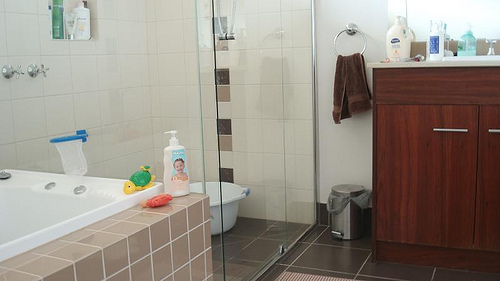Please provide a short description for this region: [0.61, 0.58, 0.75, 0.76]. Another blue and white container situated on a bathtub. 